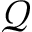Convert formula to latex. <formula><loc_0><loc_0><loc_500><loc_500>\mathcal { Q }</formula> 